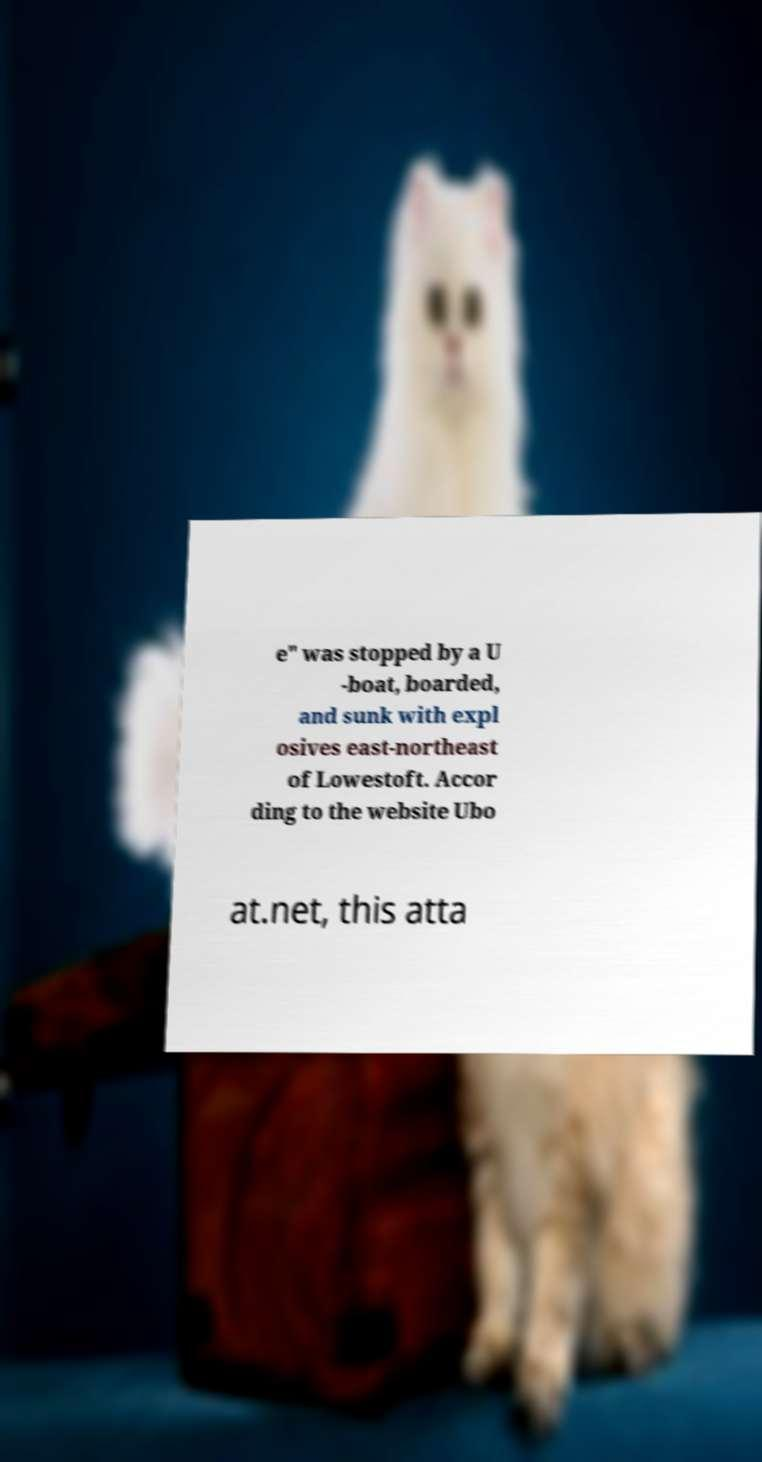Could you extract and type out the text from this image? e" was stopped by a U -boat, boarded, and sunk with expl osives east-northeast of Lowestoft. Accor ding to the website Ubo at.net, this atta 